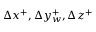Convert formula to latex. <formula><loc_0><loc_0><loc_500><loc_500>\Delta x ^ { + } , \Delta y _ { w } ^ { + } , \Delta z ^ { + }</formula> 